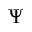<formula> <loc_0><loc_0><loc_500><loc_500>\Psi</formula> 